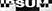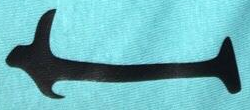What words are shown in these images in order, separated by a semicolon? IPSUM; I 